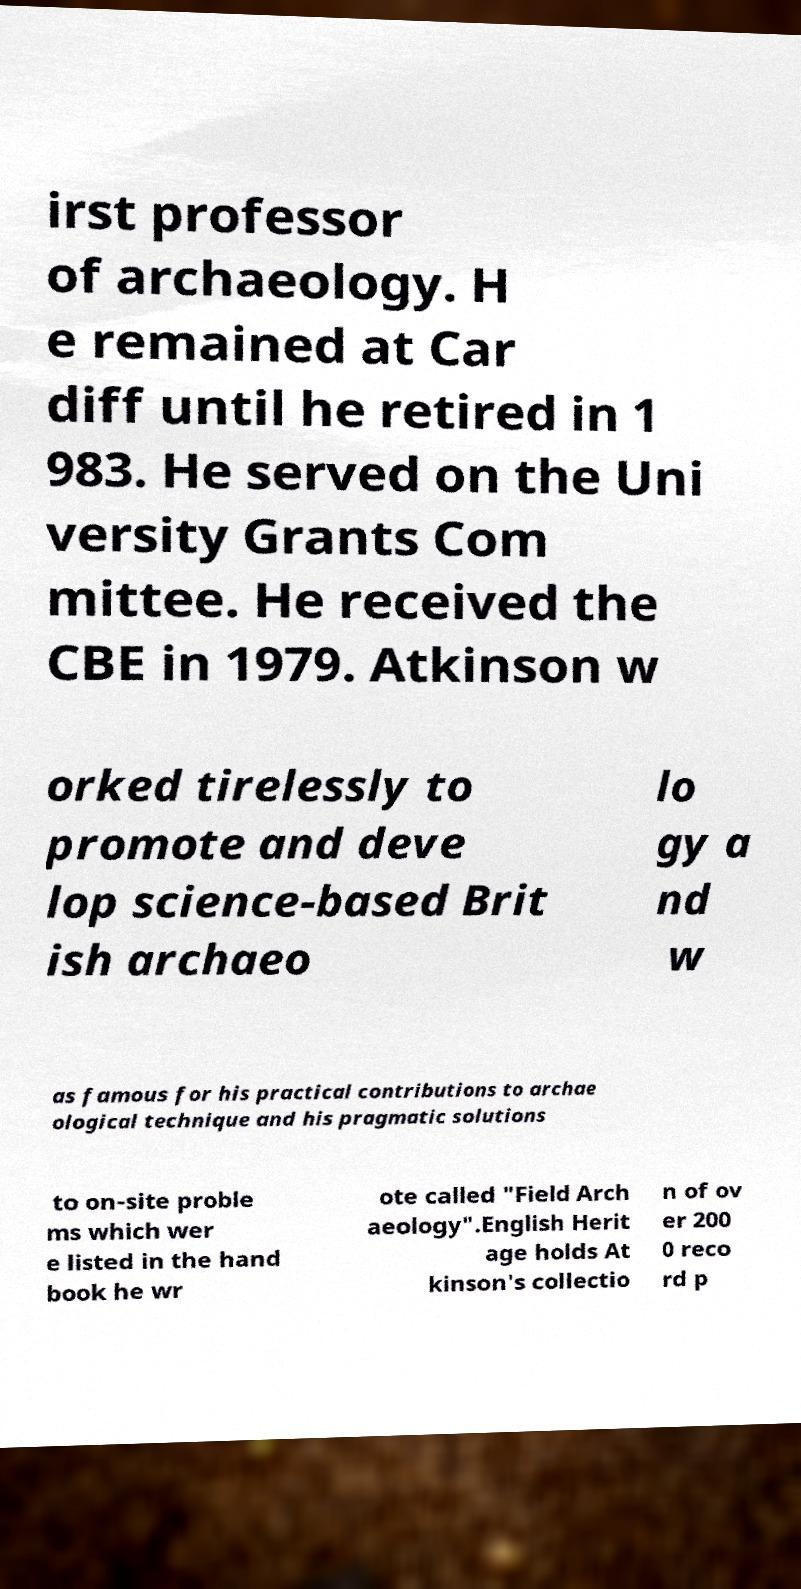There's text embedded in this image that I need extracted. Can you transcribe it verbatim? irst professor of archaeology. H e remained at Car diff until he retired in 1 983. He served on the Uni versity Grants Com mittee. He received the CBE in 1979. Atkinson w orked tirelessly to promote and deve lop science-based Brit ish archaeo lo gy a nd w as famous for his practical contributions to archae ological technique and his pragmatic solutions to on-site proble ms which wer e listed in the hand book he wr ote called "Field Arch aeology".English Herit age holds At kinson's collectio n of ov er 200 0 reco rd p 